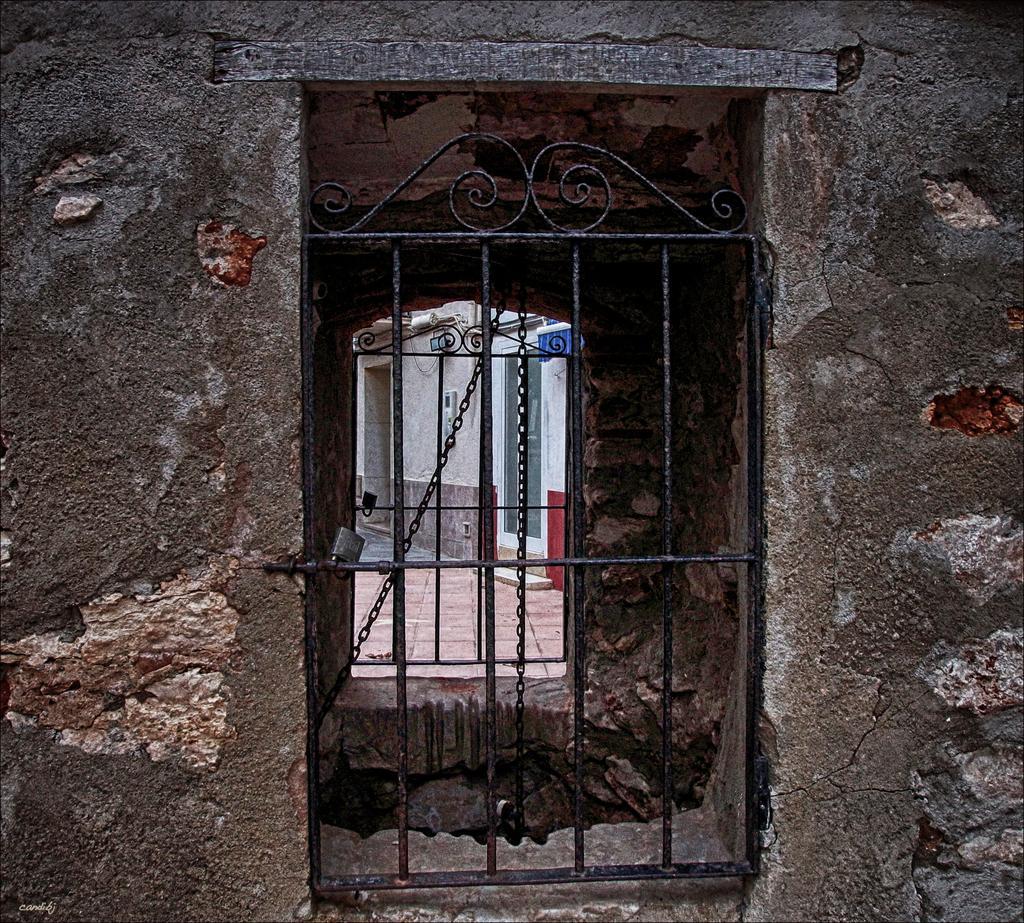Describe this image in one or two sentences. In this image we can see a house, there is a window and the gate, through the window we can see the building and a board on the wall. 